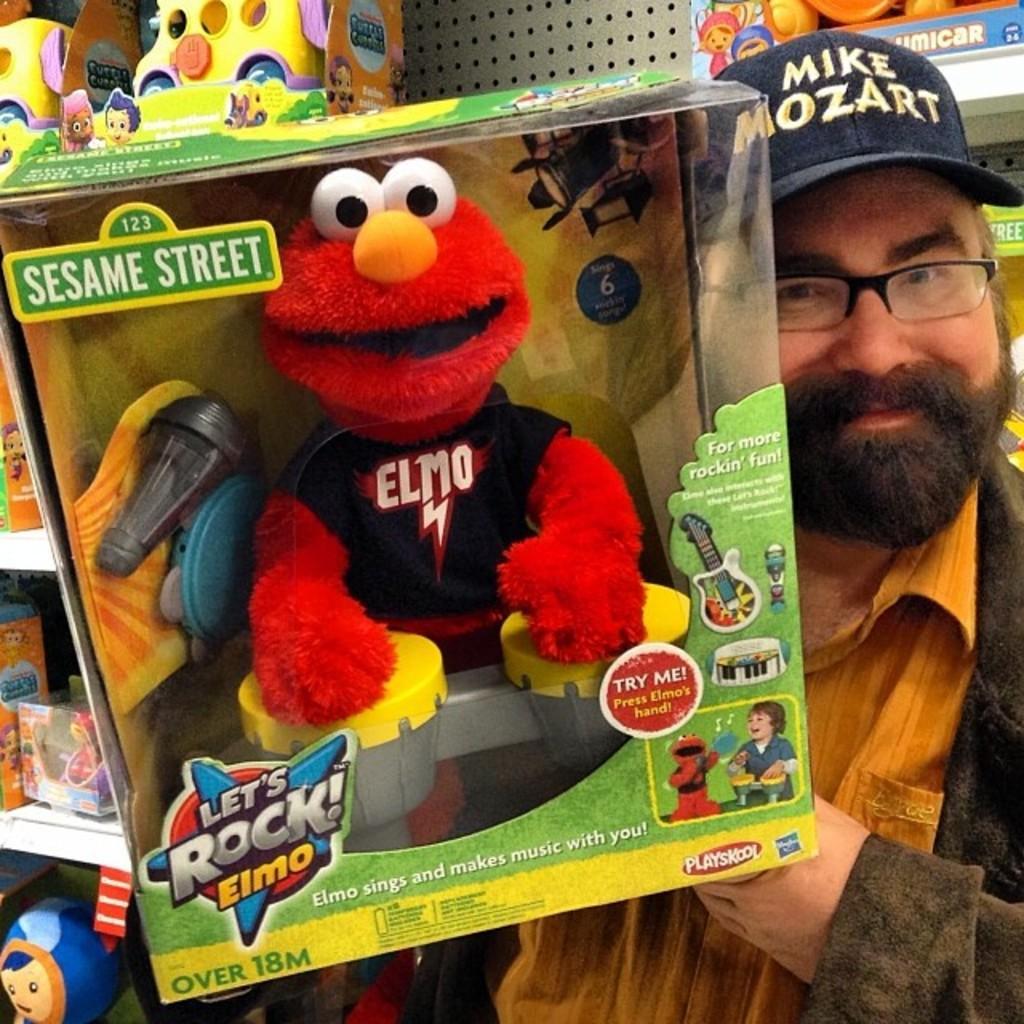Please provide a concise description of this image. In this image we can see one person wearing a cap and holding the toys. And we can see some other toys. 